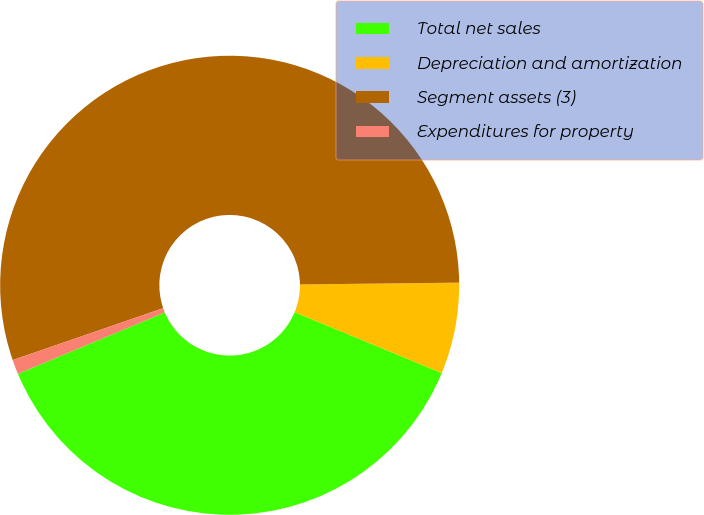<chart> <loc_0><loc_0><loc_500><loc_500><pie_chart><fcel>Total net sales<fcel>Depreciation and amortization<fcel>Segment assets (3)<fcel>Expenditures for property<nl><fcel>37.45%<fcel>6.43%<fcel>55.11%<fcel>1.02%<nl></chart> 